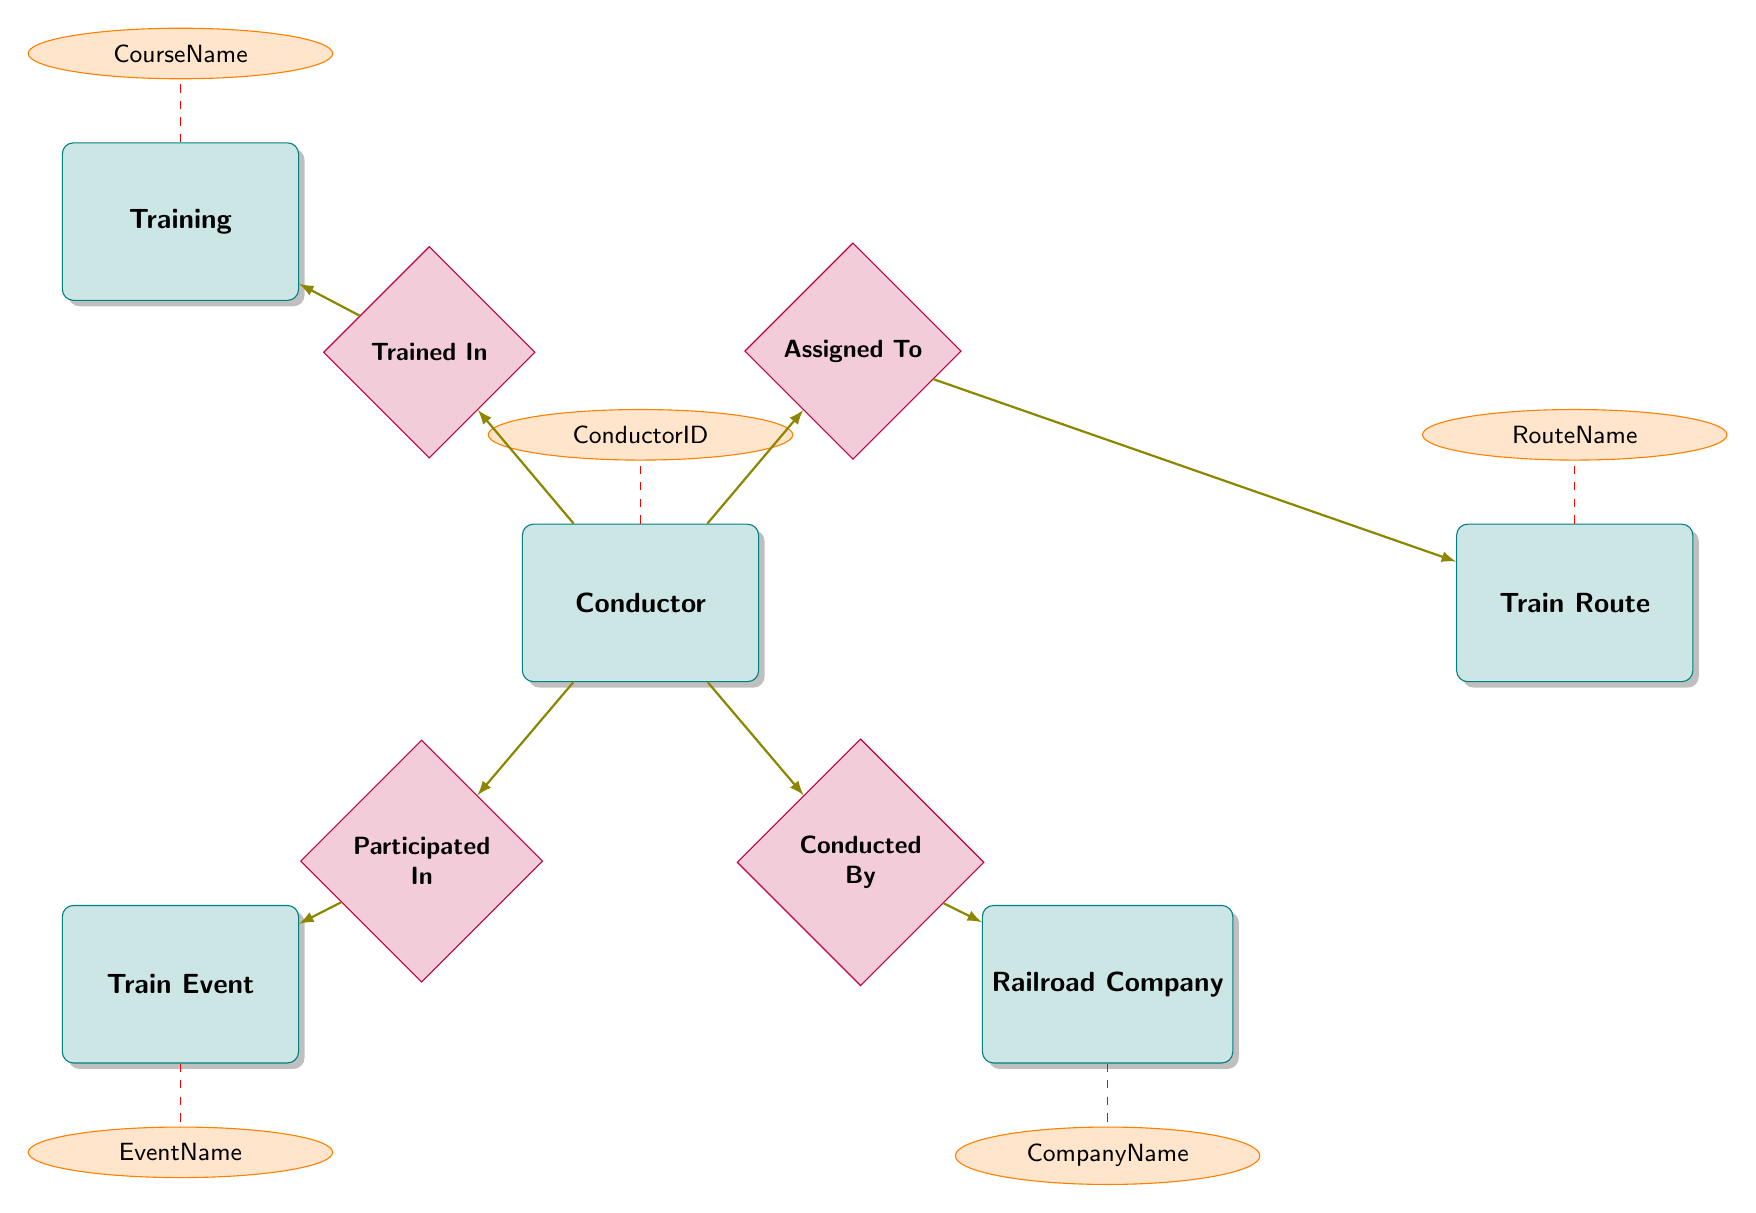What's the name of the relationship between Conductor and Railroad Company? The relationship between Conductor and Railroad Company is labeled "Conducted By", indicating how these two entities are connected in the diagram.
Answer: Conducted By How many entities are in the diagram? By counting the distinct boxes labeled in the diagram, we can identify that there are five main entities: Conductor, Railroad Company, Train Route, Train Event, and Training.
Answer: 5 What attribute is associated with the Train Event entity? The Train Event entity has an associated attribute called "EventName," as indicated by the ellipse connected to the entity box.
Answer: EventName Which entity has a relationship labeled "Assigned To"? The relationship "Assigned To" is connected to the Conductor entity, indicating that conductors are assigned to specific train routes.
Answer: Conductor What are the two entities connected by the relationship "Participated In"? The "Participated In" relationship connects the Conductor entity and the Train Event entity. This shows that conductors take part in specific events related to trains.
Answer: Conductor and Train Event What relationship connects Conductor and Training? The relationship between Conductor and Training is labeled "Trained In," indicating that conductors undergo specific training sessions.
Answer: Trained In Which entity represents the overall organization that employs the conductor? The Railroad Company entity represents the organization that employs the conductor, as denoted by its position and the relationship "Conducted By."
Answer: Railroad Company What is the attribute linked to the Training entity? The Training entity includes an attribute called "CourseName," representing the name of the training program that conductors participate in.
Answer: CourseName During what time frame is a TrainRoute assigned to a Conductor? The TrainRoute assigned to a Conductor is associated with a time frame that includes the attributes StartDate and EndDate, reflecting the period of assignment.
Answer: StartDate and EndDate 